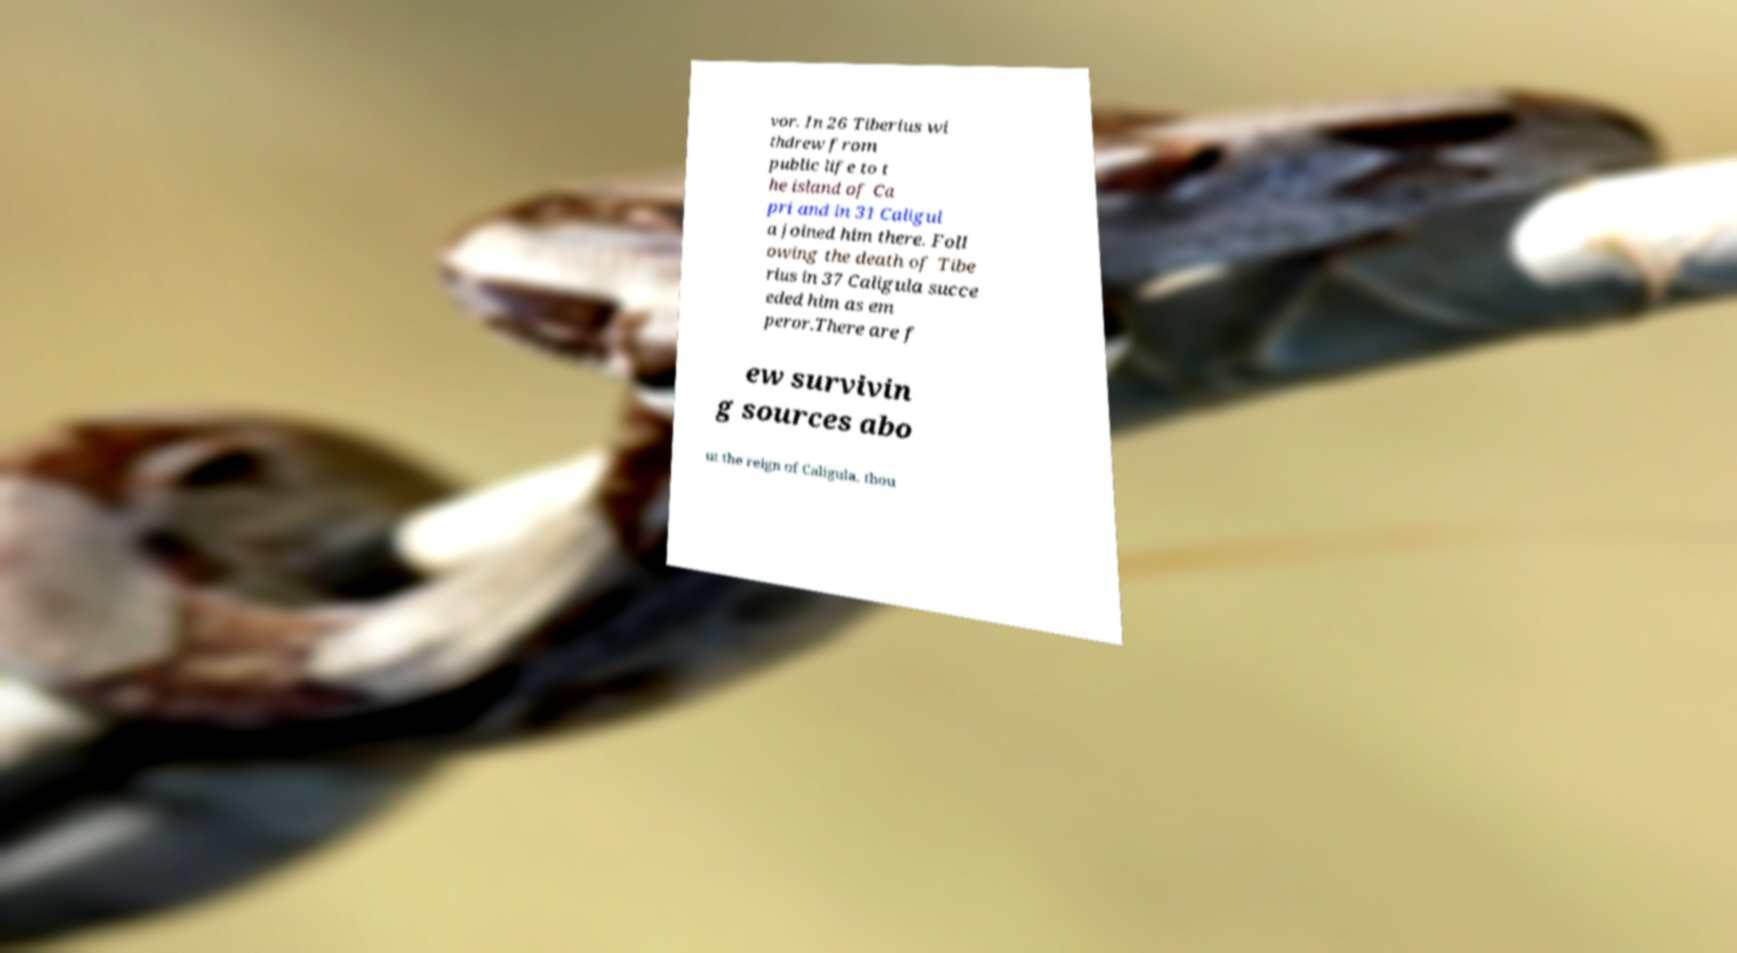I need the written content from this picture converted into text. Can you do that? vor. In 26 Tiberius wi thdrew from public life to t he island of Ca pri and in 31 Caligul a joined him there. Foll owing the death of Tibe rius in 37 Caligula succe eded him as em peror.There are f ew survivin g sources abo ut the reign of Caligula, thou 